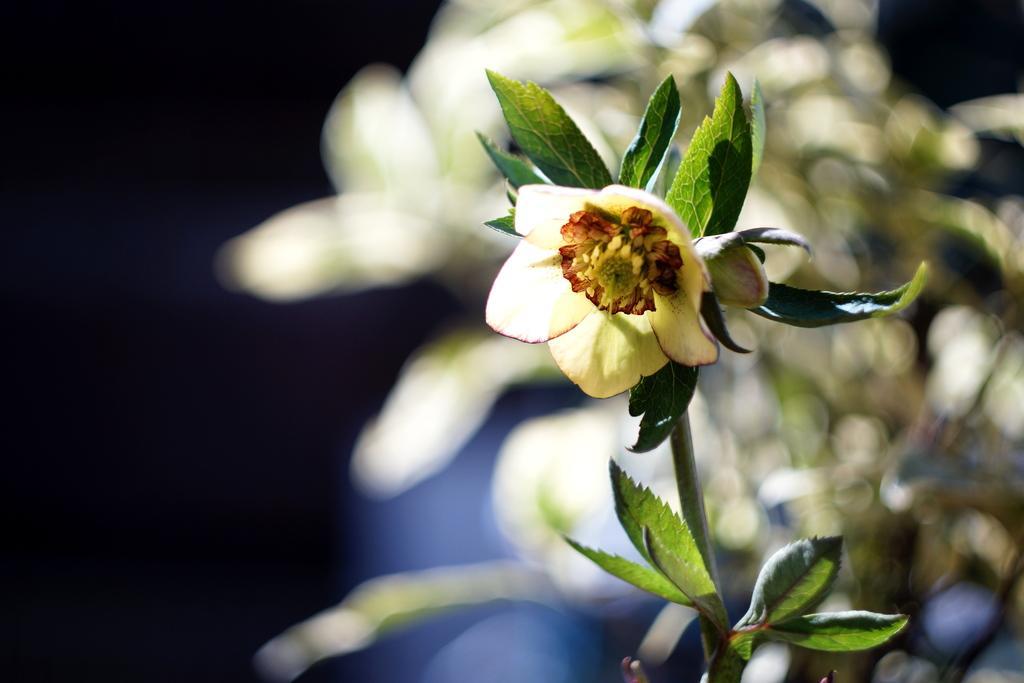Could you give a brief overview of what you see in this image? In this picture we can see a flower and leaves in the front, it looks like a plant on the right side, there is a blurry background. 